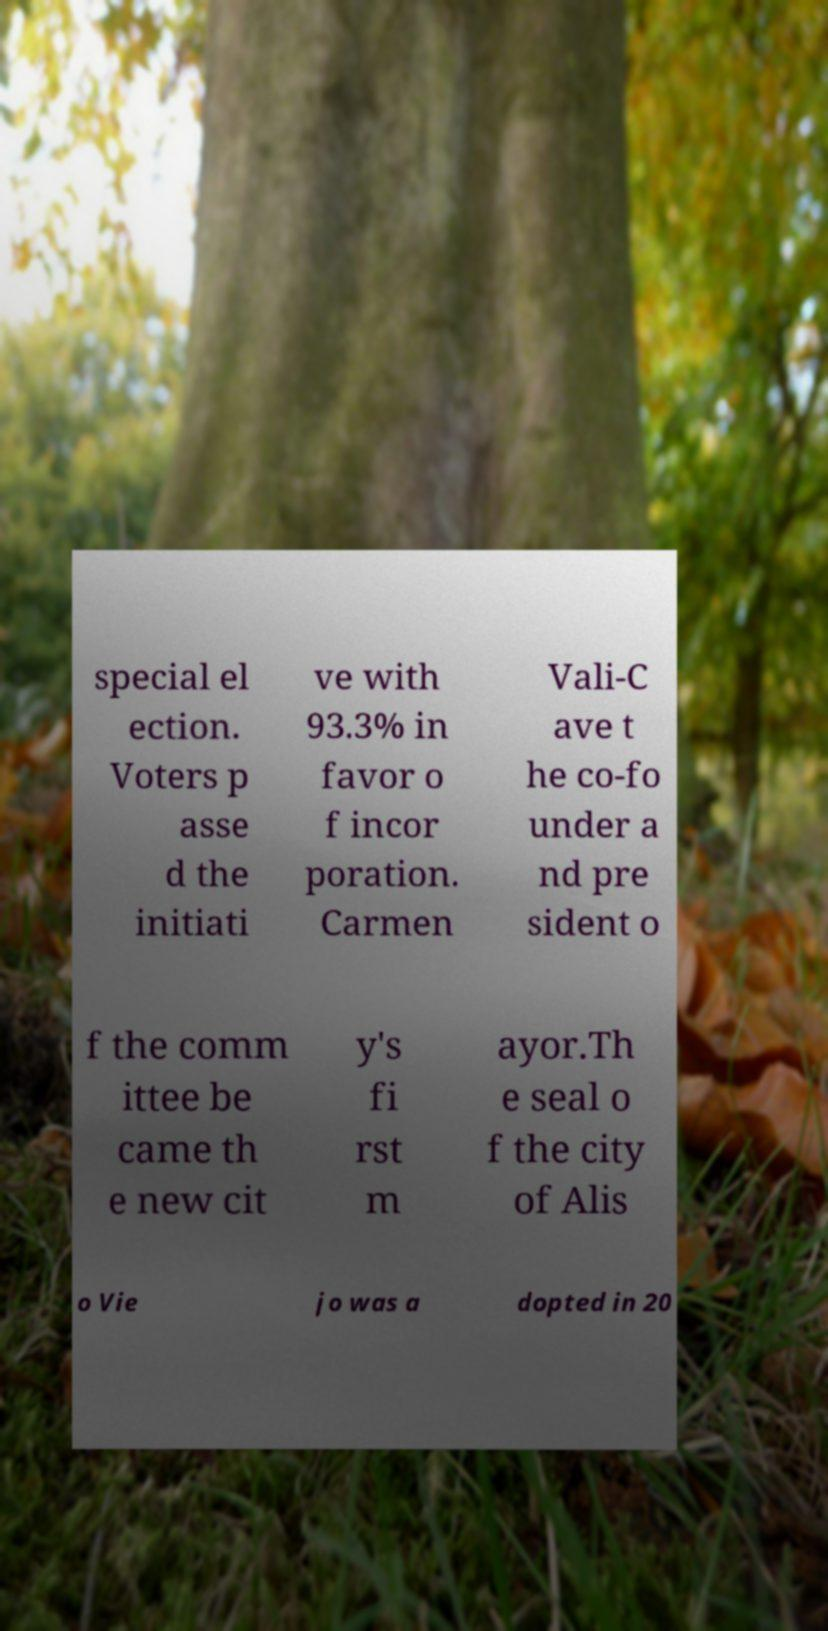Could you extract and type out the text from this image? special el ection. Voters p asse d the initiati ve with 93.3% in favor o f incor poration. Carmen Vali-C ave t he co-fo under a nd pre sident o f the comm ittee be came th e new cit y's fi rst m ayor.Th e seal o f the city of Alis o Vie jo was a dopted in 20 